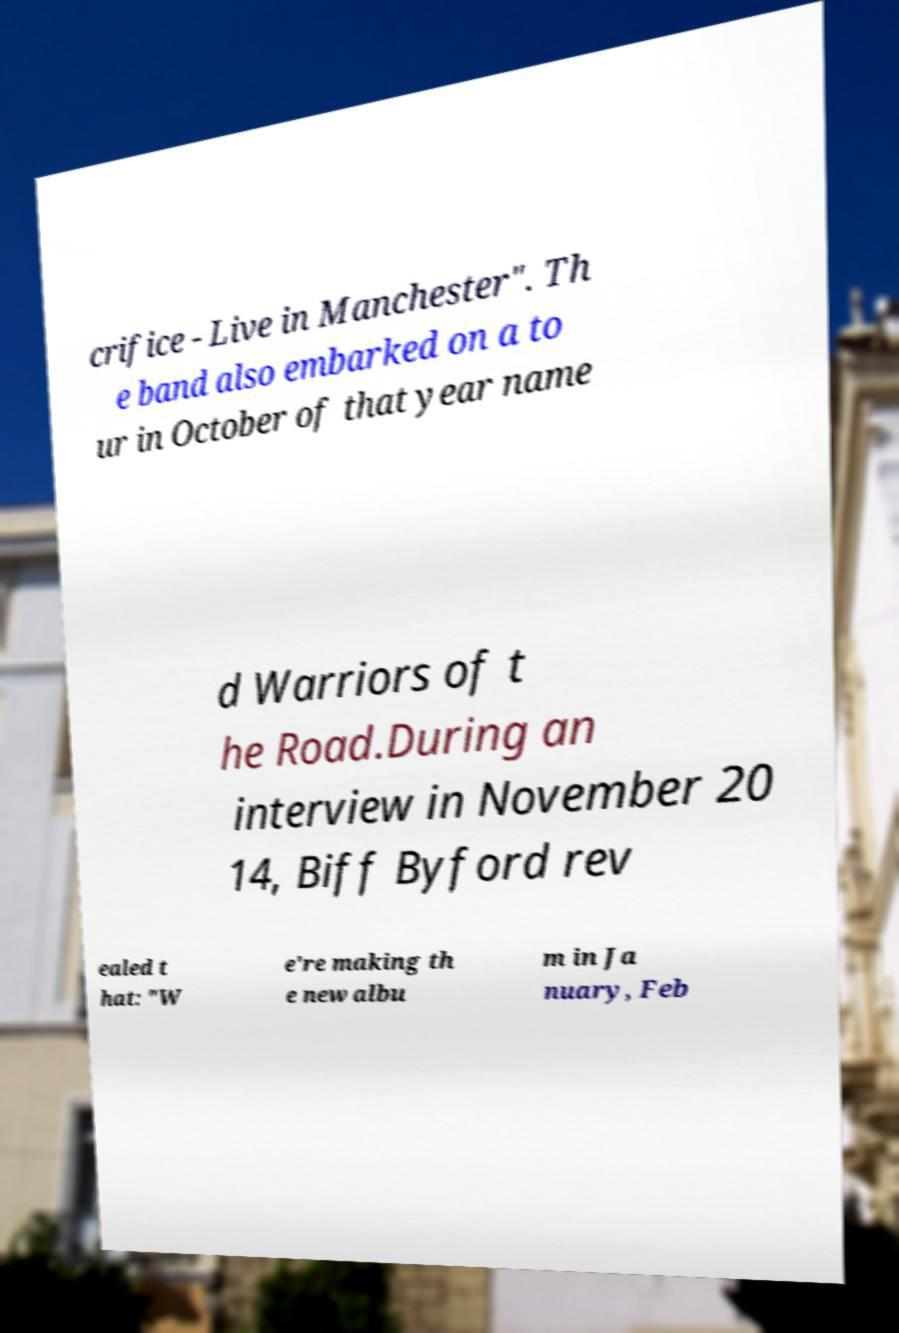Can you read and provide the text displayed in the image?This photo seems to have some interesting text. Can you extract and type it out for me? crifice - Live in Manchester". Th e band also embarked on a to ur in October of that year name d Warriors of t he Road.During an interview in November 20 14, Biff Byford rev ealed t hat: "W e're making th e new albu m in Ja nuary, Feb 